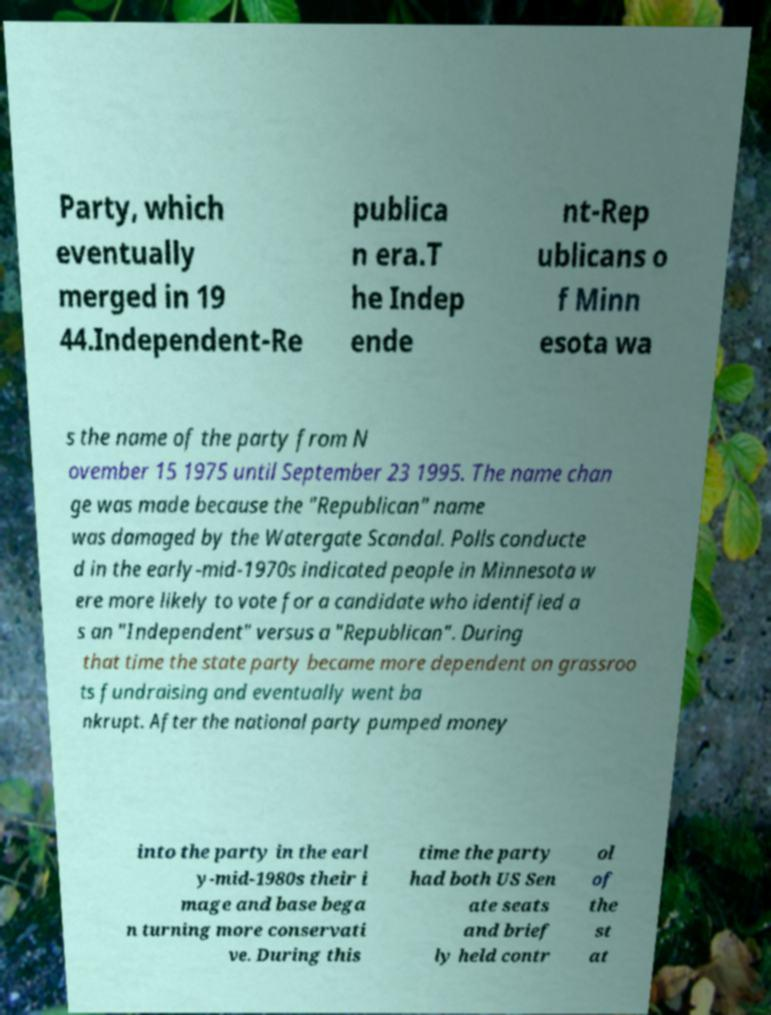Please identify and transcribe the text found in this image. Party, which eventually merged in 19 44.Independent-Re publica n era.T he Indep ende nt-Rep ublicans o f Minn esota wa s the name of the party from N ovember 15 1975 until September 23 1995. The name chan ge was made because the "Republican" name was damaged by the Watergate Scandal. Polls conducte d in the early-mid-1970s indicated people in Minnesota w ere more likely to vote for a candidate who identified a s an "Independent" versus a "Republican". During that time the state party became more dependent on grassroo ts fundraising and eventually went ba nkrupt. After the national party pumped money into the party in the earl y-mid-1980s their i mage and base bega n turning more conservati ve. During this time the party had both US Sen ate seats and brief ly held contr ol of the st at 